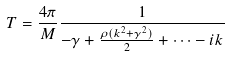<formula> <loc_0><loc_0><loc_500><loc_500>T = \frac { 4 \pi } { M } \frac { 1 } { - \gamma + \frac { \rho ( k ^ { 2 } + \gamma ^ { 2 } ) } { 2 } + \dots - i k }</formula> 